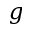<formula> <loc_0><loc_0><loc_500><loc_500>g</formula> 